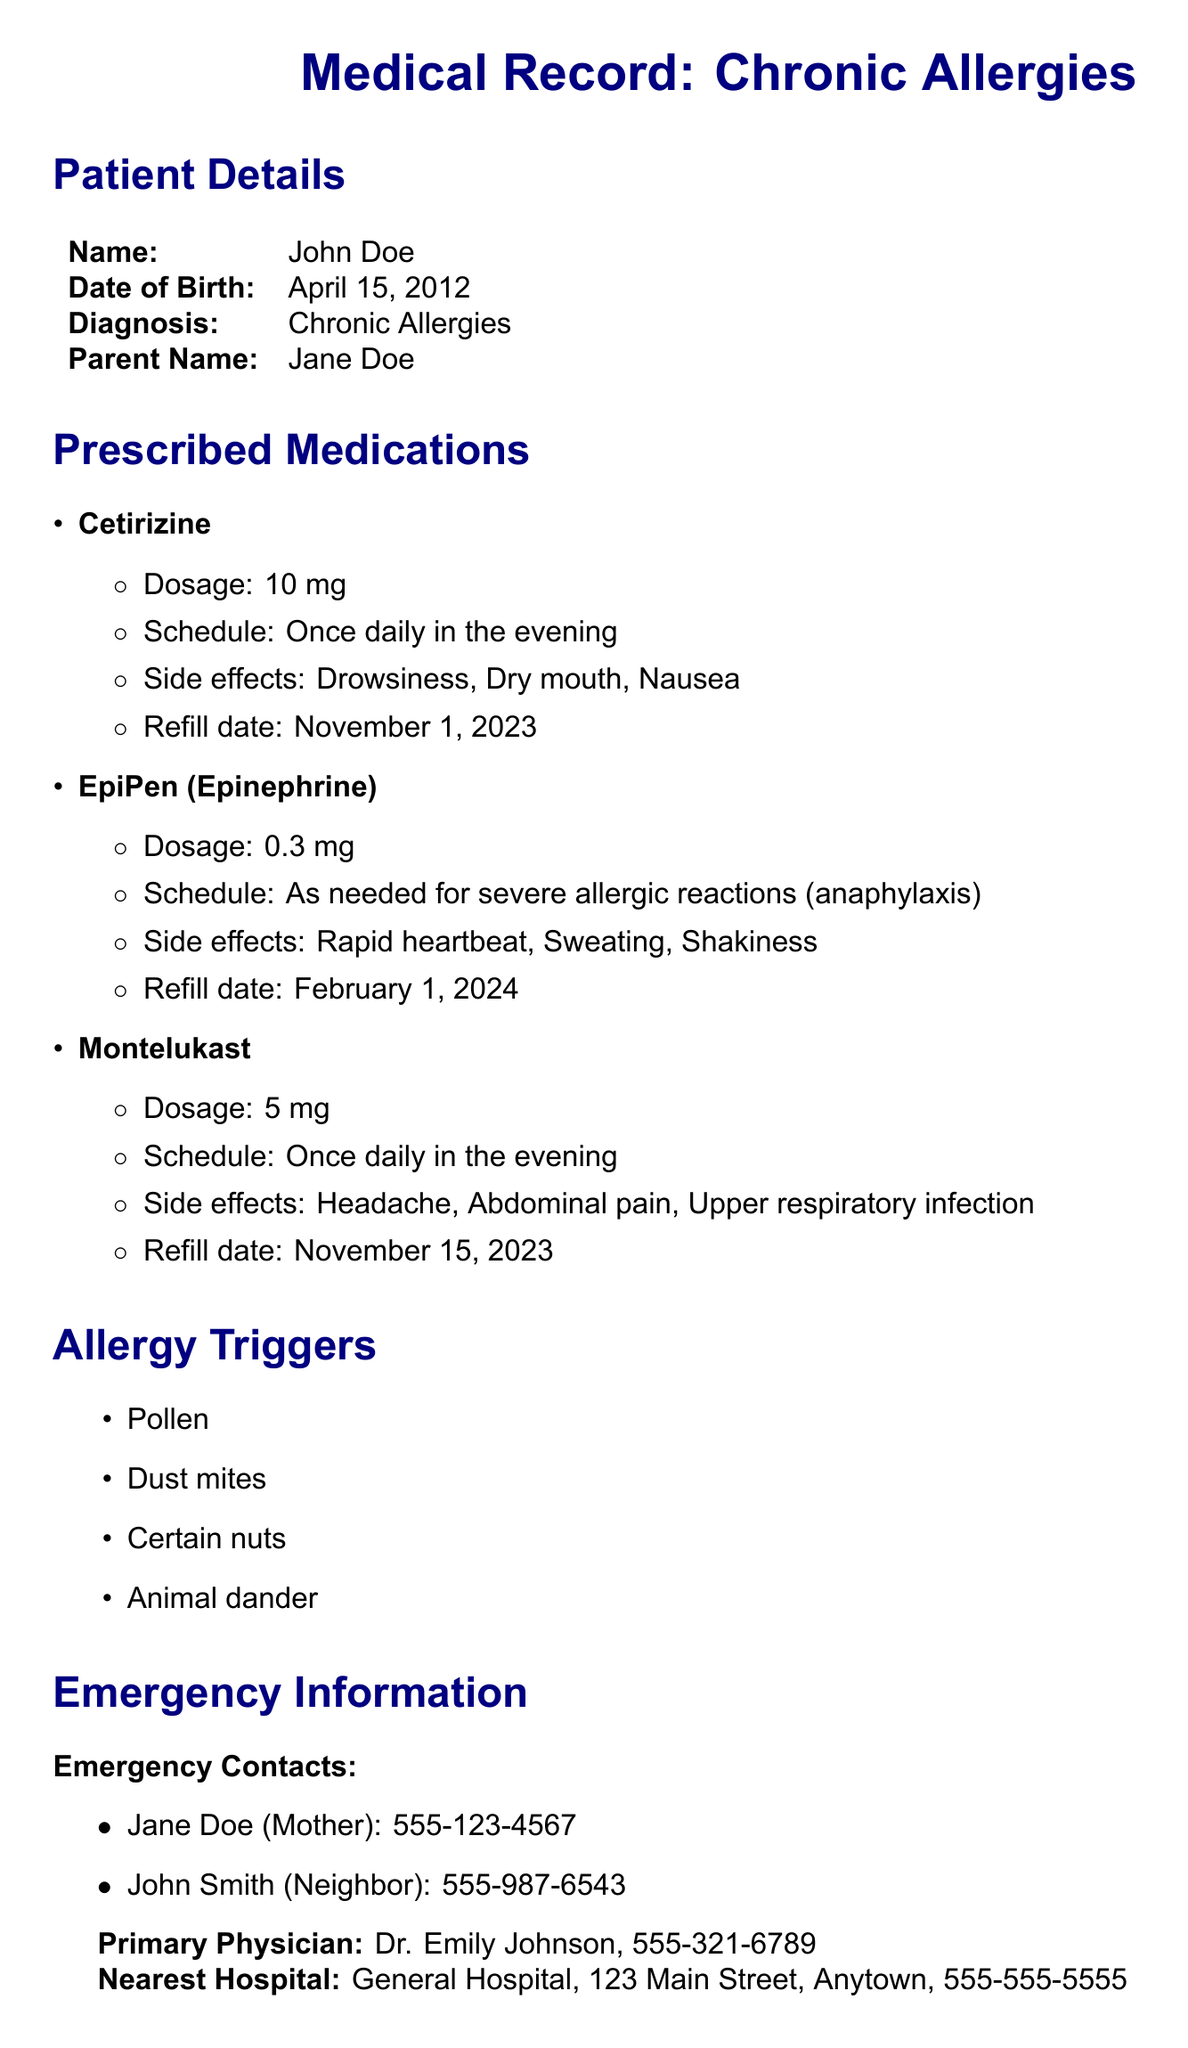What is the name of the patient? The patient's name is mentioned in the patient details section of the document.
Answer: John Doe What is the dosage of Cetirizine? The dosage is specified in the prescribed medications section for Cetirizine.
Answer: 10 mg When should Montelukast be taken? The schedule for Montelukast is noted in the prescribed medications section.
Answer: Once daily in the evening What are the side effects of the EpiPen? The side effects are listed under the prescribed medications section for the EpiPen.
Answer: Rapid heartbeat, Sweating, Shakiness What is the refill date for Cetirizine? The refill date is mentioned in the medications section specifically for Cetirizine.
Answer: November 1, 2023 What triggers John Doe's allergies? The allergy triggers are outlined in a bullet list in the document.
Answer: Pollen, Dust mites, Certain nuts, Animal dander Who is the primary physician? The primary physician's name is provided in the emergency information section.
Answer: Dr. Emily Johnson What is the phone number of the mother? The phone number is included in the emergency contacts section for Jane Doe.
Answer: 555-123-4567 When is follow-up necessary according to the Important Note for Parents? The Important Note for Parents states the need for follow-up appointments.
Answer: Regularly 